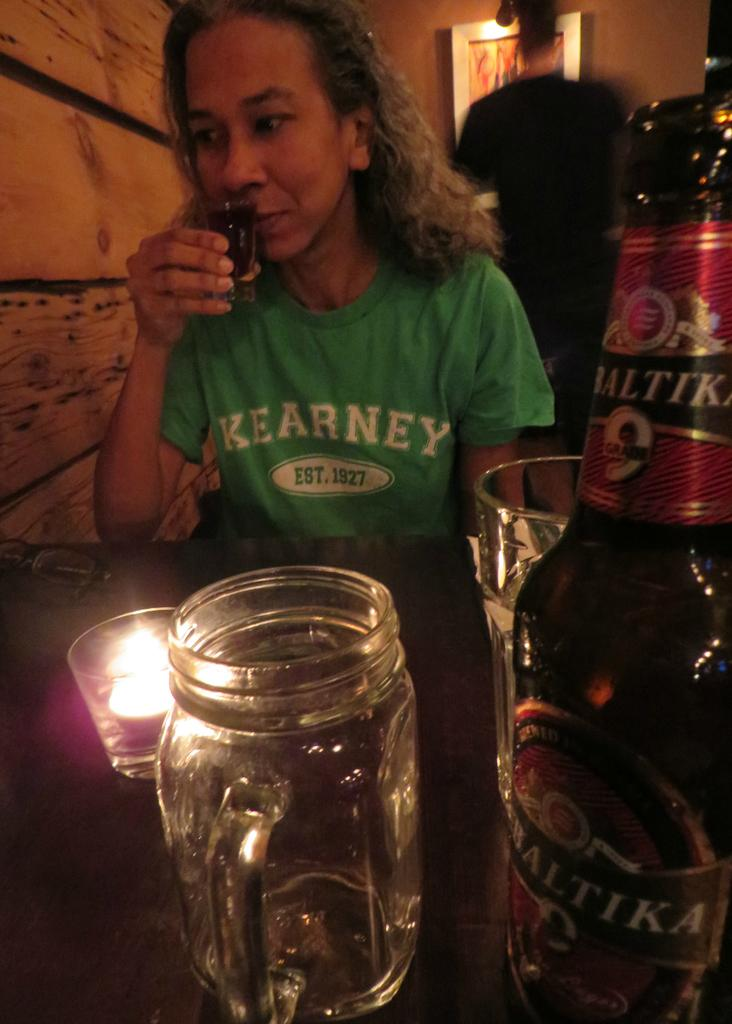<image>
Share a concise interpretation of the image provided. a woman wearing a green kearney shirt est. in 1927 